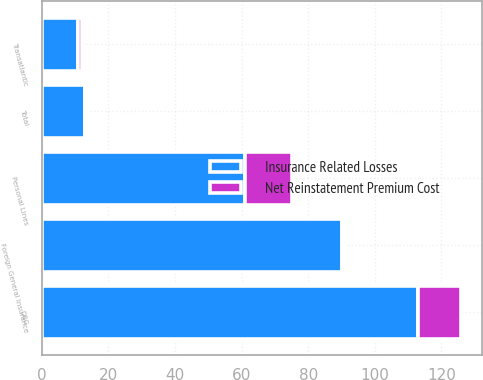Convert chart. <chart><loc_0><loc_0><loc_500><loc_500><stacked_bar_chart><ecel><fcel>DBG<fcel>Transatlantic<fcel>Personal Lines<fcel>Foreign General Insurance<fcel>Total<nl><fcel>Insurance Related Losses<fcel>113<fcel>11<fcel>61<fcel>90<fcel>13<nl><fcel>Net Reinstatement Premium Cost<fcel>13<fcel>1<fcel>14<fcel>1<fcel>1<nl></chart> 